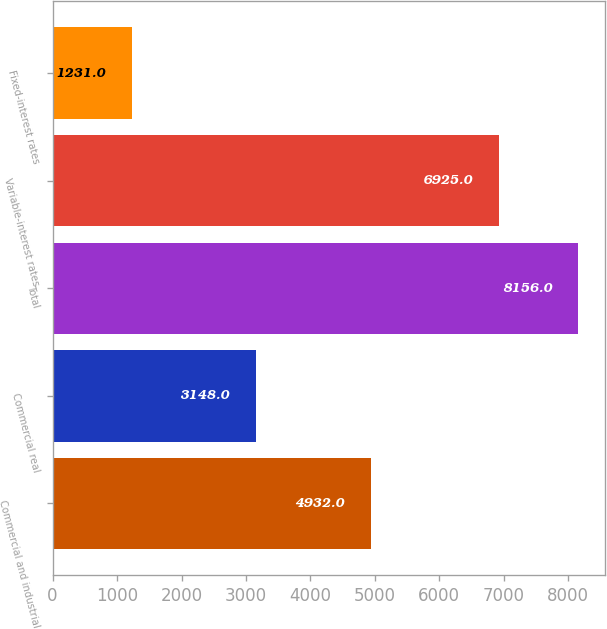<chart> <loc_0><loc_0><loc_500><loc_500><bar_chart><fcel>Commercial and industrial<fcel>Commercial real<fcel>Total<fcel>Variable-interest rates<fcel>Fixed-interest rates<nl><fcel>4932<fcel>3148<fcel>8156<fcel>6925<fcel>1231<nl></chart> 